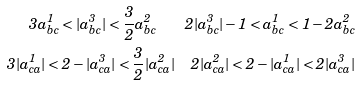<formula> <loc_0><loc_0><loc_500><loc_500>3 a ^ { 1 } _ { b c } < | a ^ { 3 } _ { b c } | < \frac { 3 } { 2 } a ^ { 2 } _ { b c } \quad 2 | a ^ { 3 } _ { b c } | - 1 < a ^ { 1 } _ { b c } < 1 - 2 a ^ { 2 } _ { b c } \\ 3 | a ^ { 1 } _ { c a } | < 2 - | a ^ { 3 } _ { c a } | < \frac { 3 } { 2 } | a ^ { 2 } _ { c a } | \quad 2 | a ^ { 2 } _ { c a } | < 2 - | a ^ { 1 } _ { c a } | < 2 | a ^ { 3 } _ { c a } |</formula> 